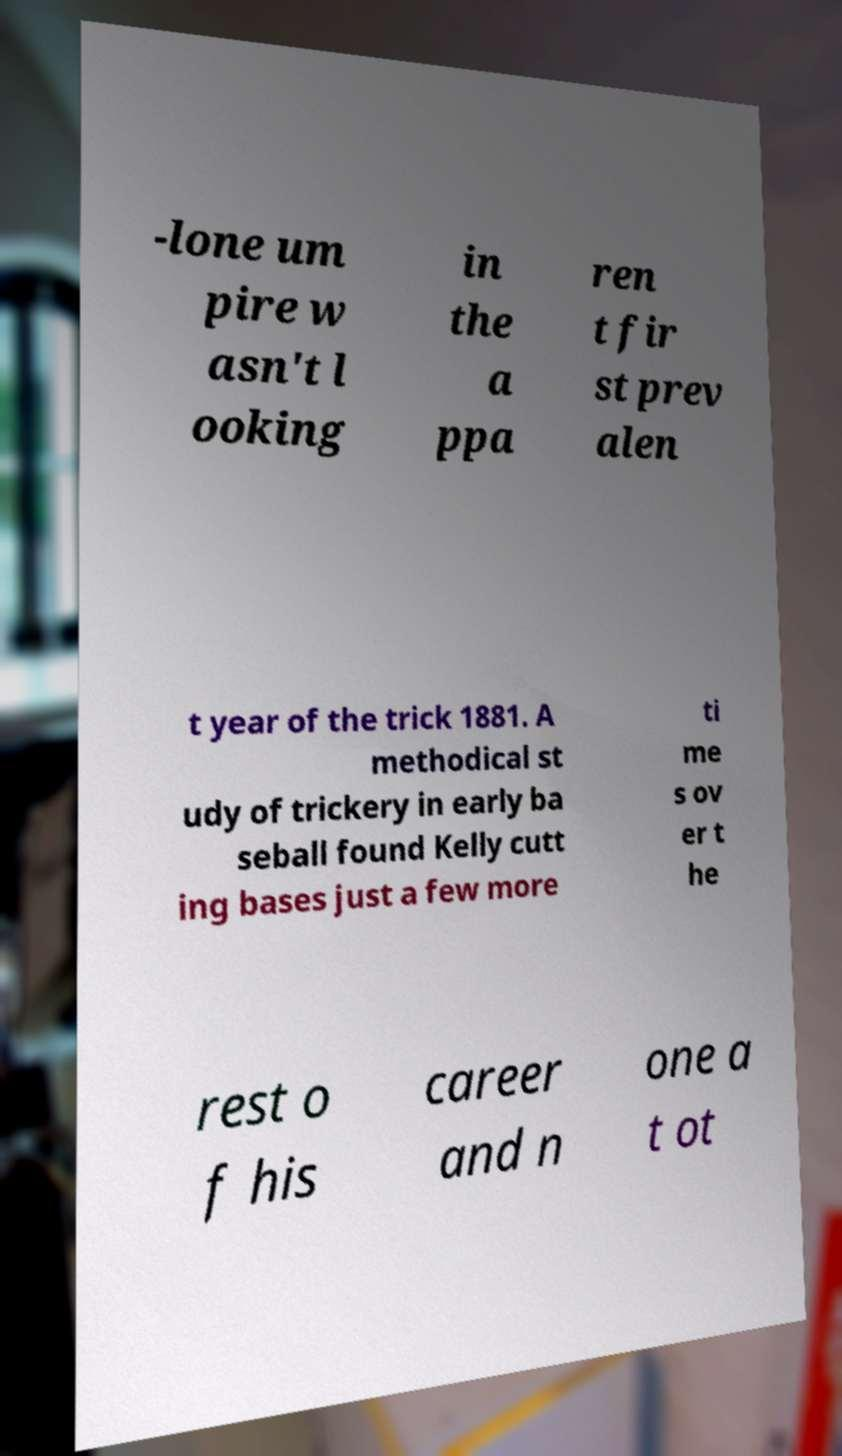I need the written content from this picture converted into text. Can you do that? -lone um pire w asn't l ooking in the a ppa ren t fir st prev alen t year of the trick 1881. A methodical st udy of trickery in early ba seball found Kelly cutt ing bases just a few more ti me s ov er t he rest o f his career and n one a t ot 